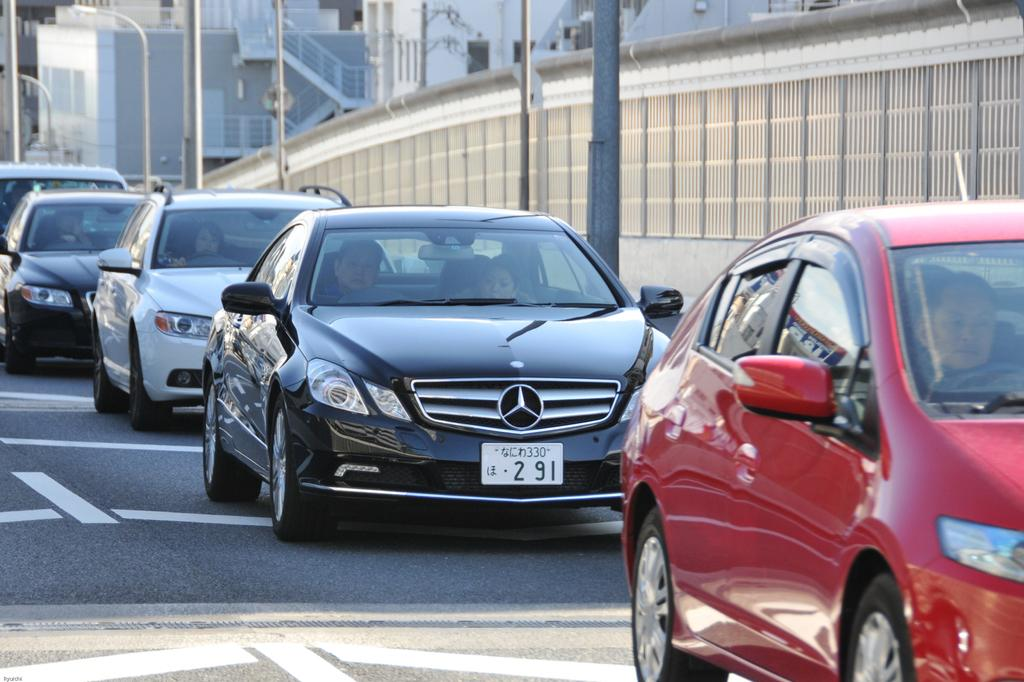What is happening on the road in the image? There are vehicles on the road in the image, and people are sitting in them. What can be seen in the background of the image? There are buildings and poles in the background of the image. What type of coal is being used to color the flesh of the people in the image? There is no coal or mention of coloring the flesh of people in the image. The image shows vehicles on the road with people sitting in them, and buildings and poles in the background. 